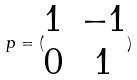<formula> <loc_0><loc_0><loc_500><loc_500>p = ( \begin{matrix} 1 & - 1 \\ 0 & 1 \end{matrix} )</formula> 